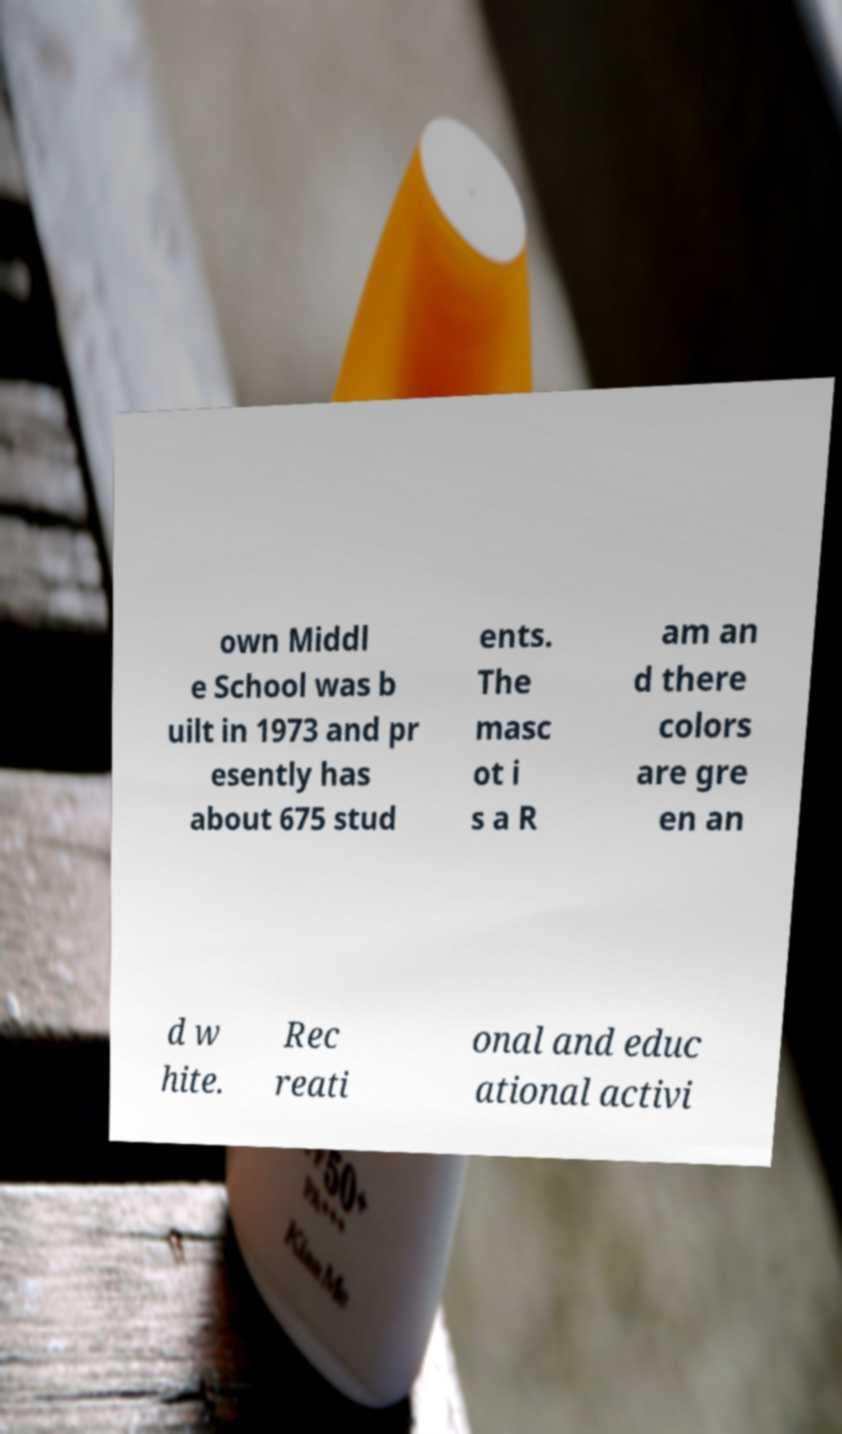There's text embedded in this image that I need extracted. Can you transcribe it verbatim? own Middl e School was b uilt in 1973 and pr esently has about 675 stud ents. The masc ot i s a R am an d there colors are gre en an d w hite. Rec reati onal and educ ational activi 